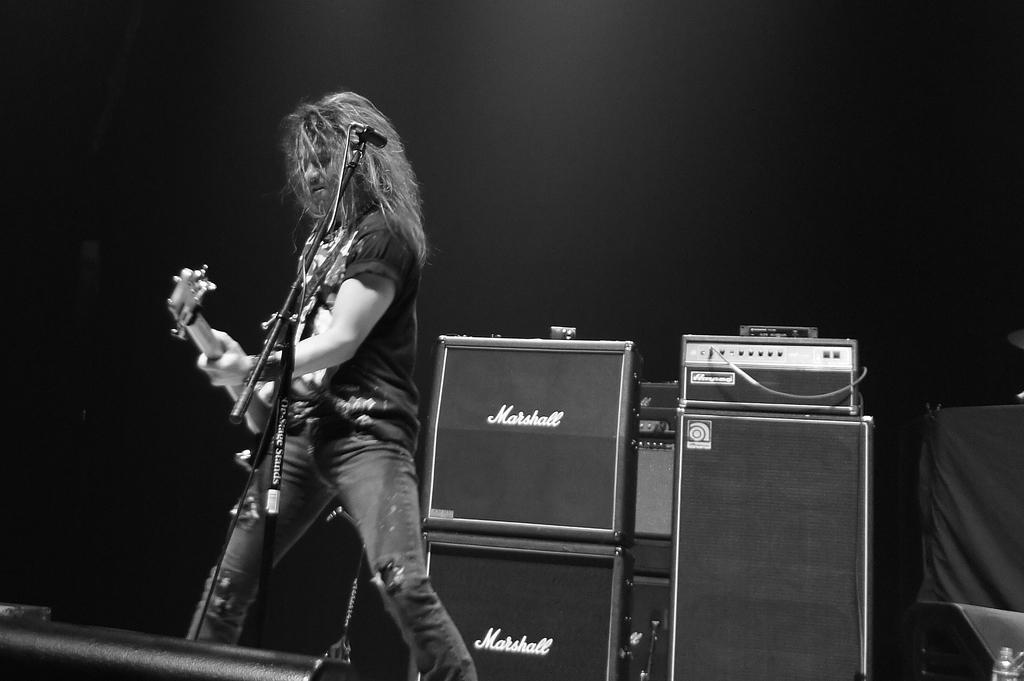<image>
Write a terse but informative summary of the picture. A musician and Marshall branded speakers behind him. 